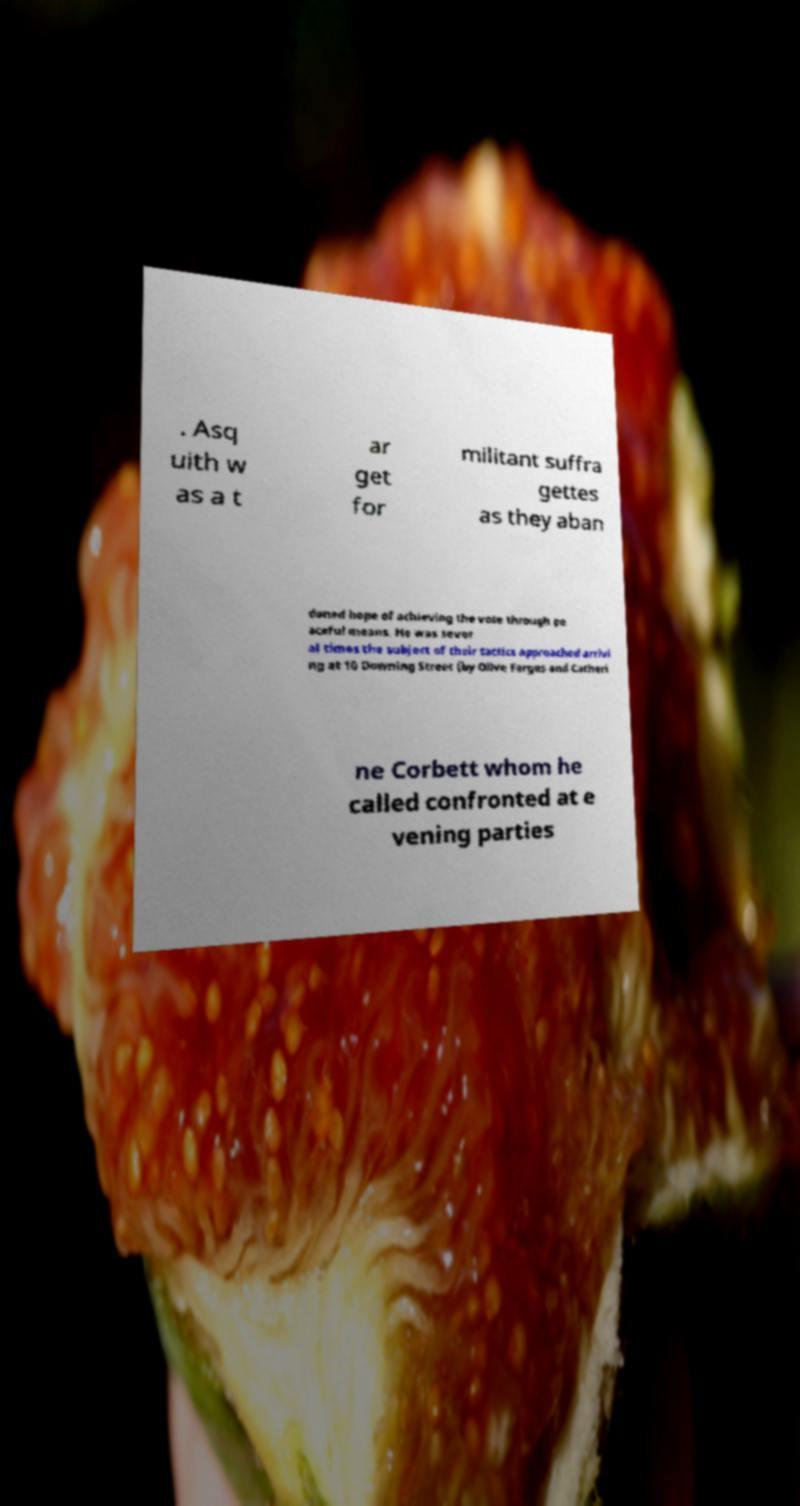What messages or text are displayed in this image? I need them in a readable, typed format. . Asq uith w as a t ar get for militant suffra gettes as they aban doned hope of achieving the vote through pe aceful means. He was sever al times the subject of their tactics approached arrivi ng at 10 Downing Street (by Olive Fargus and Catheri ne Corbett whom he called confronted at e vening parties 